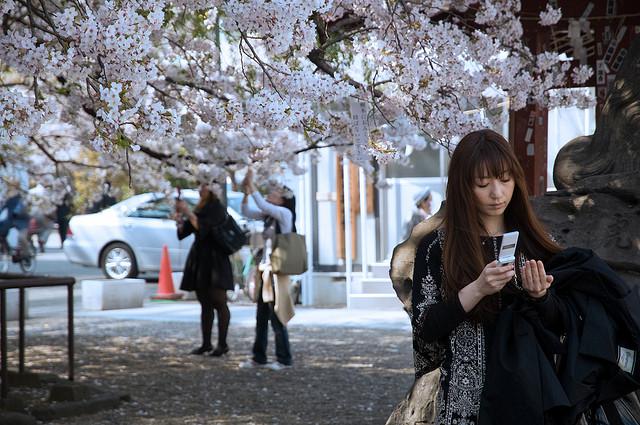Could this be at a zoo?
Write a very short answer. No. What color are the blooms?
Quick response, please. White. What is in the woman hand?
Concise answer only. Phone. What colors can be seen in this picture?
Be succinct. White and black. Are there bikes in the photo?
Quick response, please. No. How many people are talking on their phones?
Quick response, please. 0. What are the objects behind the post?
Write a very short answer. Trees. Are these two women walking in the rain?
Concise answer only. No. What color is the cone shaped object?
Keep it brief. Orange. Which people are more likely to be tourists?
Short answer required. People in background. What are the trees in the background?
Write a very short answer. Cherry blossoms. 